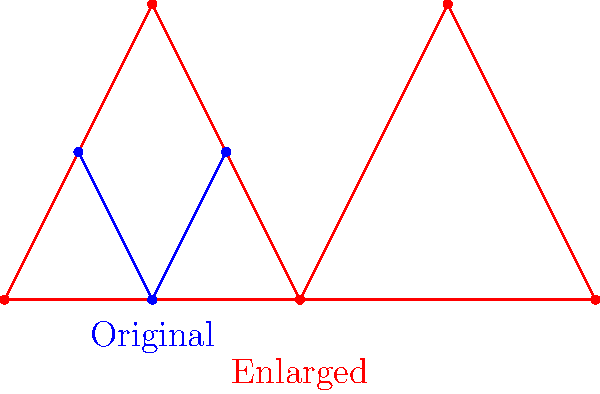Hey fellow YouTubers! Check out this cool geometry challenge! We have two star-shaped figures: a blue one and a red one. The red star is an enlargement of the blue star. Can you figure out the scale factor used to create the red star from the blue one? This could be a great topic for our next videos! Let's solve this step-by-step:

1) To find the scale factor, we need to compare corresponding sides or distances in the original and enlarged figures.

2) Let's focus on the width of the stars. In the original (blue) star:
   - The width is from x=0 to x=4, so the width is 4 units.

3) In the enlarged (red) star:
   - The width is from x=0 to x=8, so the width is 8 units.

4) To calculate the scale factor, we divide the new dimension by the original dimension:

   $$ \text{Scale Factor} = \frac{\text{New Dimension}}{\text{Original Dimension}} = \frac{8}{4} = 2 $$

5) We can verify this by checking other dimensions:
   - Original height: 2 units
   - Enlarged height: 4 units
   $$ \frac{4}{2} = 2 $$

   This confirms our scale factor.

6) Therefore, the red star is twice as large as the blue star in all dimensions.
Answer: 2 